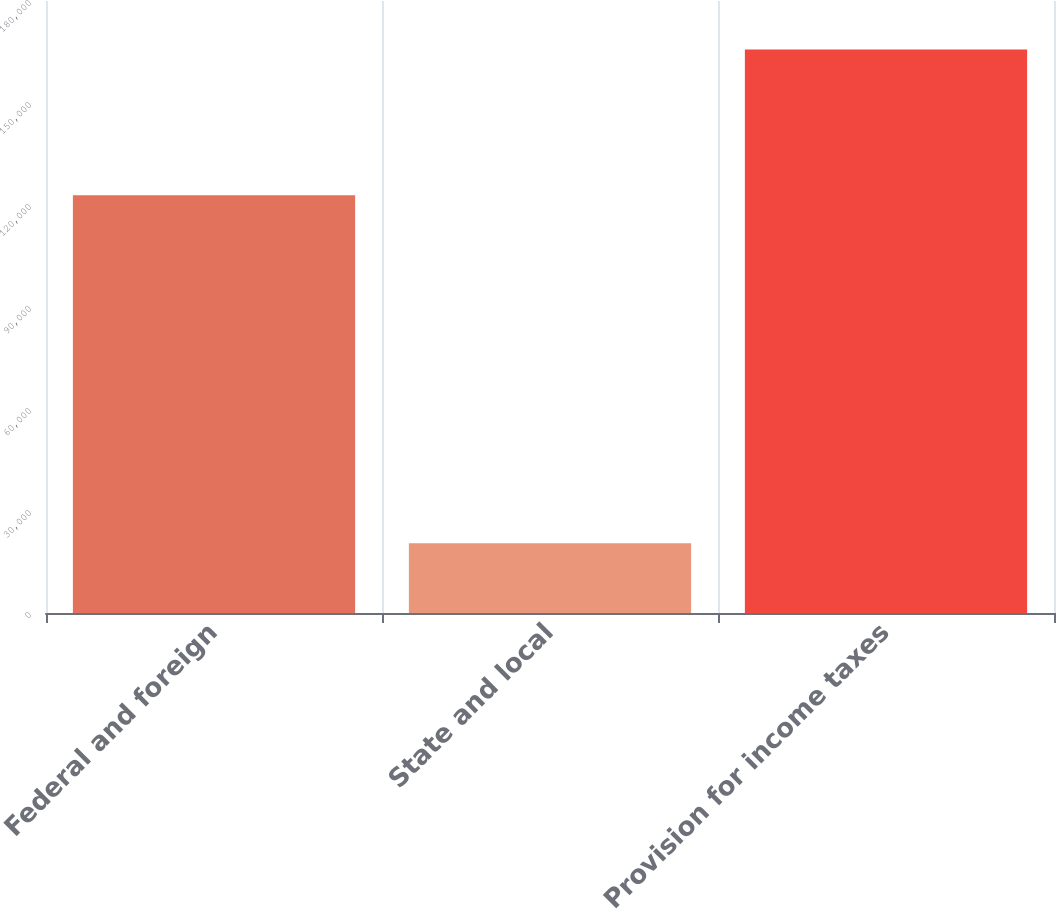Convert chart to OTSL. <chart><loc_0><loc_0><loc_500><loc_500><bar_chart><fcel>Federal and foreign<fcel>State and local<fcel>Provision for income taxes<nl><fcel>122872<fcel>20523<fcel>165739<nl></chart> 